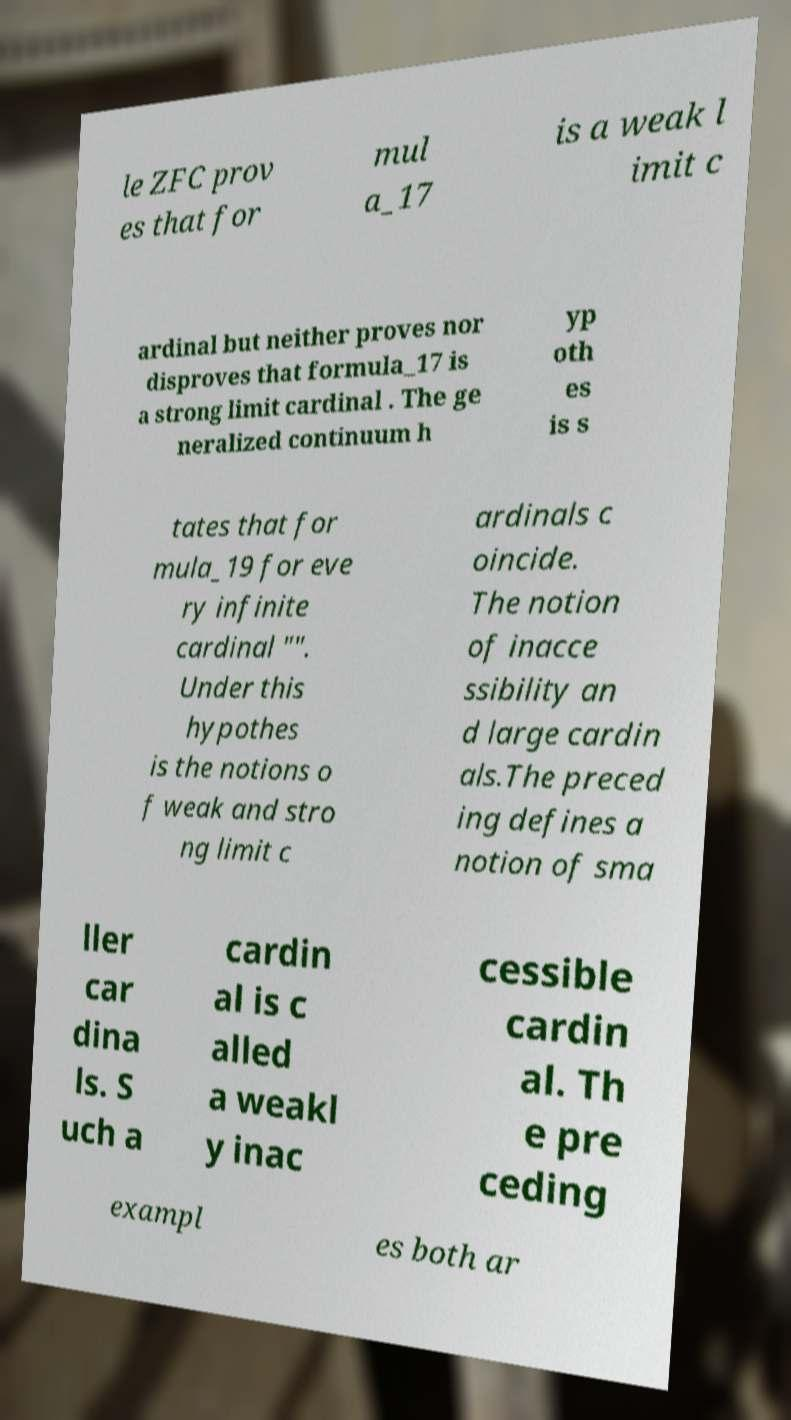I need the written content from this picture converted into text. Can you do that? le ZFC prov es that for mul a_17 is a weak l imit c ardinal but neither proves nor disproves that formula_17 is a strong limit cardinal . The ge neralized continuum h yp oth es is s tates that for mula_19 for eve ry infinite cardinal "". Under this hypothes is the notions o f weak and stro ng limit c ardinals c oincide. The notion of inacce ssibility an d large cardin als.The preced ing defines a notion of sma ller car dina ls. S uch a cardin al is c alled a weakl y inac cessible cardin al. Th e pre ceding exampl es both ar 